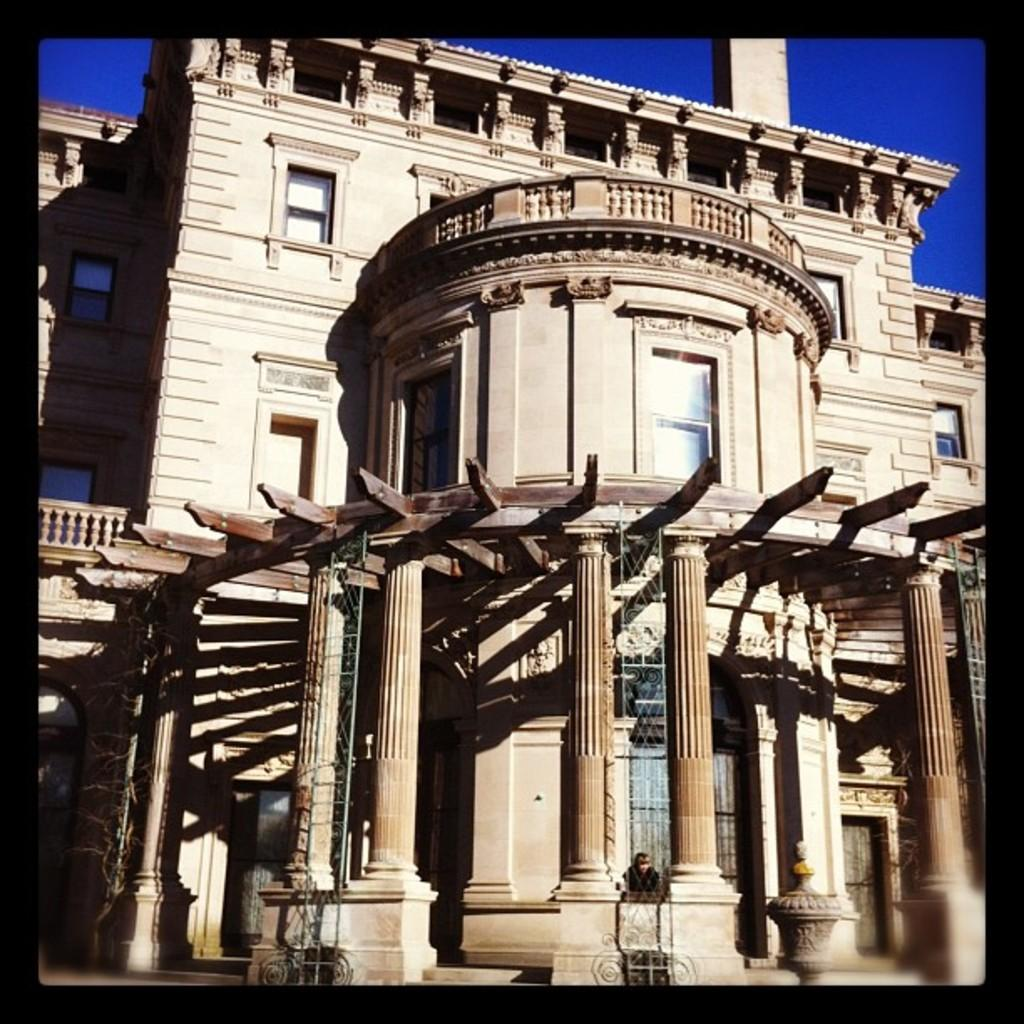What type of structure is present in the image? There is a building in the image. What colors are used for the building? The building is cream and brown in color. What feature can be seen on the building? There are windows on the building. What can be seen in the background of the image? The sky is visible in the background of the image. What is the color of the sky in the image? The sky is blue in color. Can you see any buns or butter on the building in the image? No, there are no buns or butter present on the building in the image. Is there a clover growing on the building in the image? No, there is no clover growing on the building in the image. 